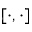<formula> <loc_0><loc_0><loc_500><loc_500>[ \cdot , \cdot ]</formula> 